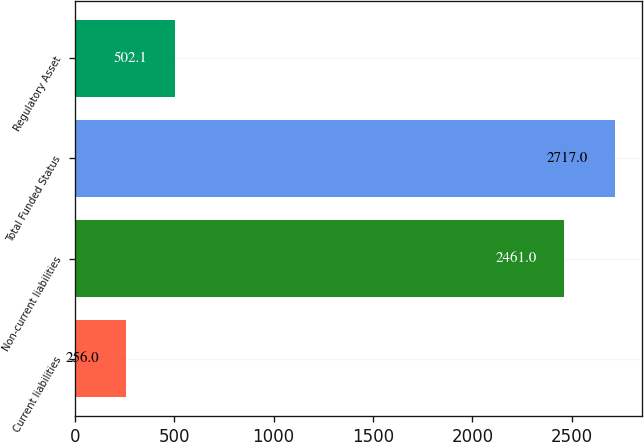Convert chart. <chart><loc_0><loc_0><loc_500><loc_500><bar_chart><fcel>Current liabilities<fcel>Non-current liabilities<fcel>Total Funded Status<fcel>Regulatory Asset<nl><fcel>256<fcel>2461<fcel>2717<fcel>502.1<nl></chart> 